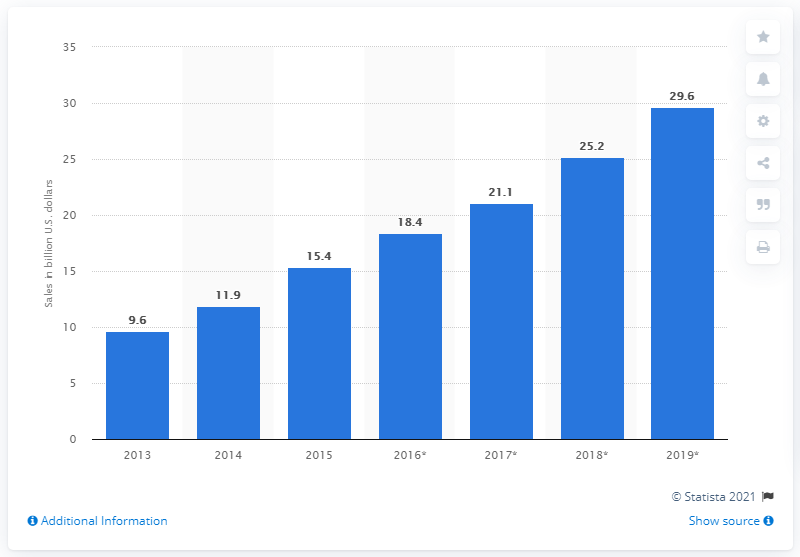Indicate a few pertinent items in this graphic. According to a source, the value of the IoT semiconductor market in 2014 was 11.9 billion dollars. 